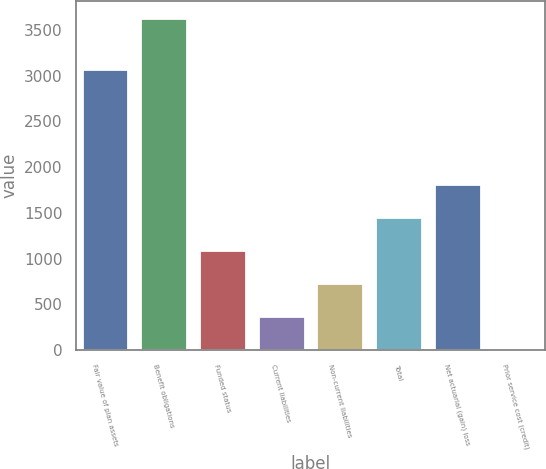<chart> <loc_0><loc_0><loc_500><loc_500><bar_chart><fcel>Fair value of plan assets<fcel>Benefit obligations<fcel>Funded status<fcel>Current liabilities<fcel>Non-current liabilities<fcel>Total<fcel>Net actuarial (gain) loss<fcel>Prior service cost (credit)<nl><fcel>3068<fcel>3633<fcel>1094.8<fcel>369.6<fcel>732.2<fcel>1457.4<fcel>1820<fcel>7<nl></chart> 